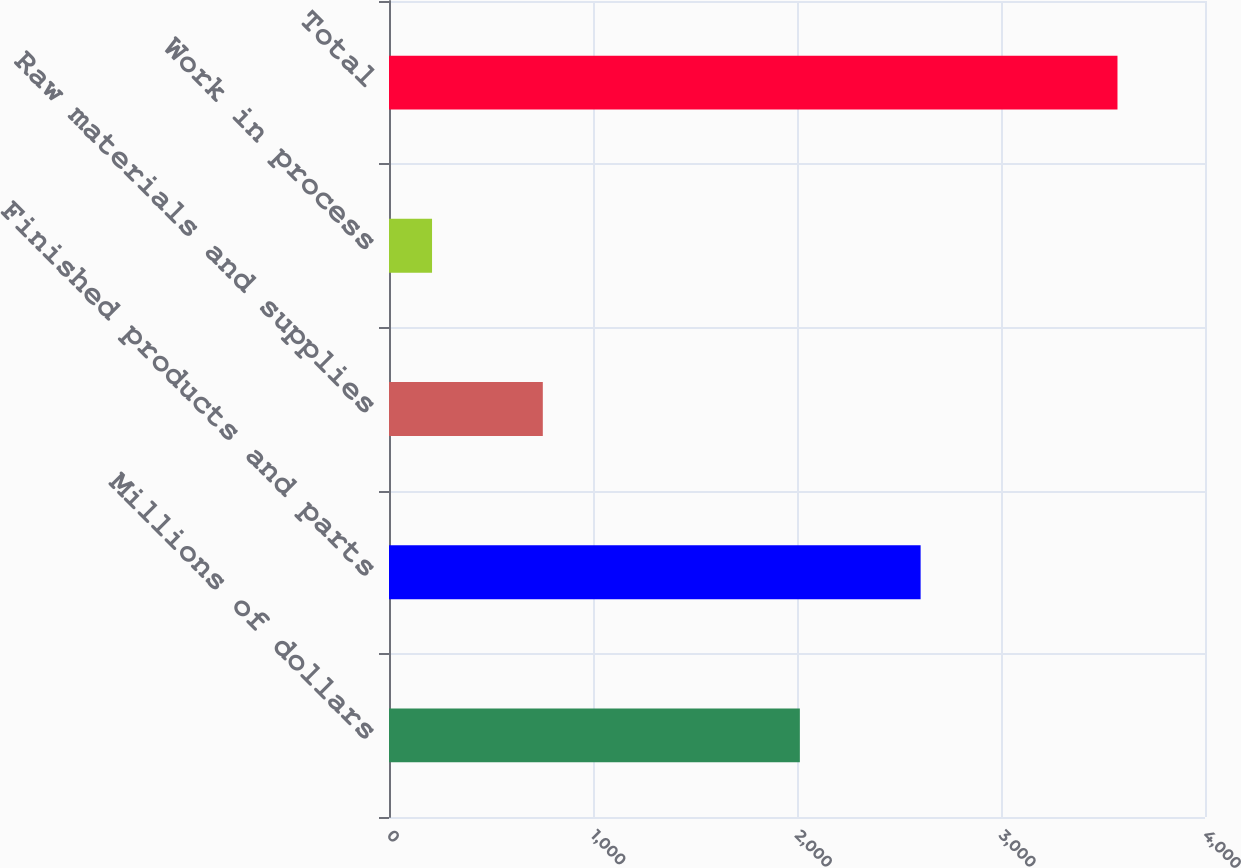Convert chart. <chart><loc_0><loc_0><loc_500><loc_500><bar_chart><fcel>Millions of dollars<fcel>Finished products and parts<fcel>Raw materials and supplies<fcel>Work in process<fcel>Total<nl><fcel>2014<fcel>2606<fcel>754<fcel>211<fcel>3571<nl></chart> 